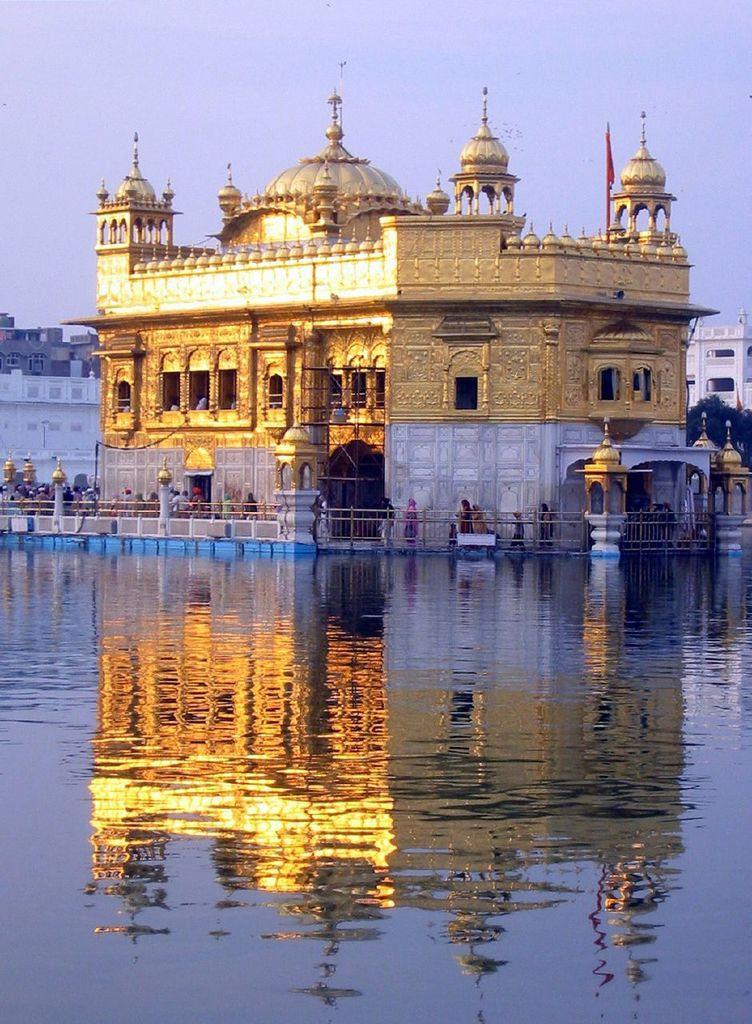In one or two sentences, can you explain what this image depicts? In this image, I can see a golden temple and few people standing. There is water. On the right side of the image, there is a tree. In the background, I can see the buildings and the sky. 